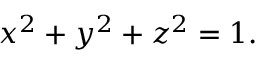<formula> <loc_0><loc_0><loc_500><loc_500>x ^ { 2 } + y ^ { 2 } + z ^ { 2 } = 1 .</formula> 